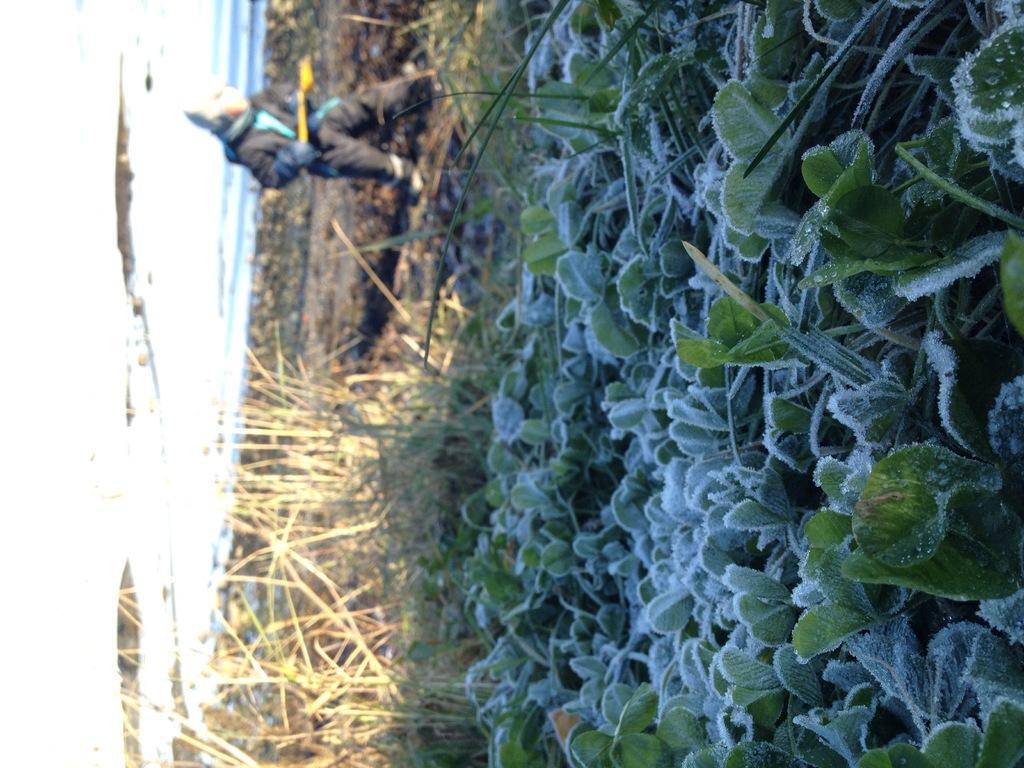How would you summarize this image in a sentence or two? This image is in left direction. On the right side, I can see few plants and grass. On the leaves I can see the water drops. In the background there is a person standing and holding an object in the hands. The background is blurred. 